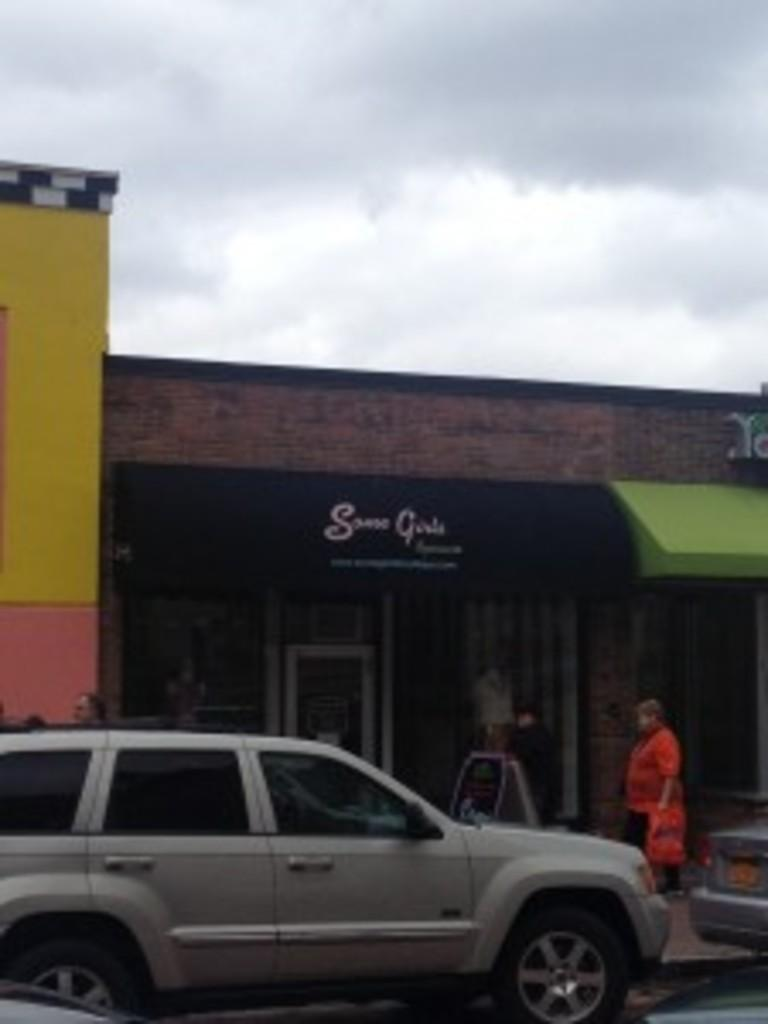What is the main subject of the image? The main subject of the image is a car on the road. What else can be seen in the image besides the car? There is a building in the middle of the image. What is visible in the sky in the background of the image? There are clouds visible in the sky in the background of the image. What type of store can be seen in the image? There is no store present in the image; it features a car on the road and a building in the middle. What kind of flowers are growing near the car in the image? There are no flowers visible in the image; it only shows a car on the road, a building, and clouds in the sky. 